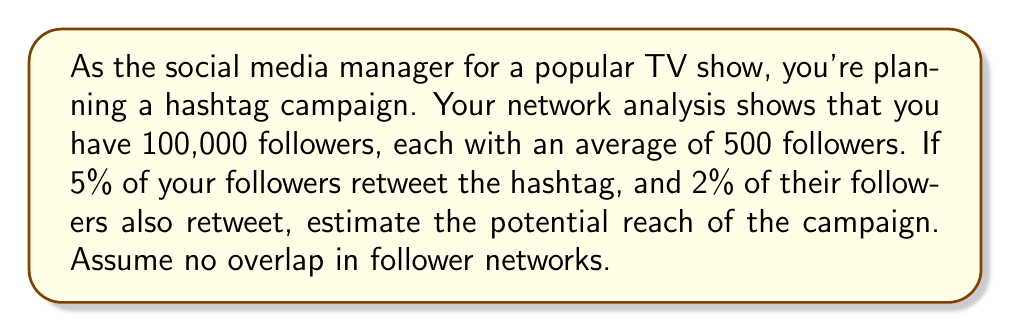Help me with this question. Let's break this down step-by-step:

1) First, calculate the number of your followers who will retweet:
   $5\% \text{ of } 100,000 = 0.05 \times 100,000 = 5,000$ followers

2) Each of these 5,000 followers has an average of 500 followers. So the total number of second-level followers reached is:
   $5,000 \times 500 = 2,500,000$ second-level followers

3) Of these second-level followers, 2% will retweet. Calculate this number:
   $2\% \text{ of } 2,500,000 = 0.02 \times 2,500,000 = 50,000$ second-level retweets

4) To get the total reach, sum up:
   - Your original followers: 100,000
   - Your followers who retweeted: 5,000
   - Second-level followers reached: 2,500,000
   - Second-level followers who retweeted: 50,000

   Total reach = $100,000 + 5,000 + 2,500,000 + 50,000 = 2,655,000$

Therefore, the estimated potential reach of the hashtag campaign is 2,655,000 users.
Answer: 2,655,000 users 